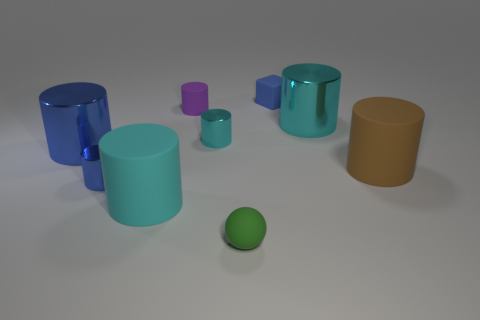Is the number of small cyan things behind the blue rubber object the same as the number of small blue things?
Ensure brevity in your answer.  No. Are there any tiny blocks that are behind the tiny cylinder left of the small purple rubber cylinder?
Ensure brevity in your answer.  Yes. How many other things are the same color as the tiny rubber sphere?
Your answer should be very brief. 0. What color is the small matte block?
Your answer should be very brief. Blue. What size is the thing that is in front of the small blue shiny cylinder and behind the small green matte object?
Provide a short and direct response. Large. What number of objects are either large cylinders that are on the left side of the small green matte thing or large brown rubber things?
Your answer should be very brief. 3. There is a tiny blue object that is made of the same material as the purple object; what is its shape?
Provide a succinct answer. Cube. The big cyan rubber thing is what shape?
Make the answer very short. Cylinder. What is the color of the big thing that is both on the left side of the purple object and on the right side of the large blue metallic cylinder?
Give a very brief answer. Cyan. What shape is the purple matte object that is the same size as the blue matte object?
Offer a very short reply. Cylinder. 